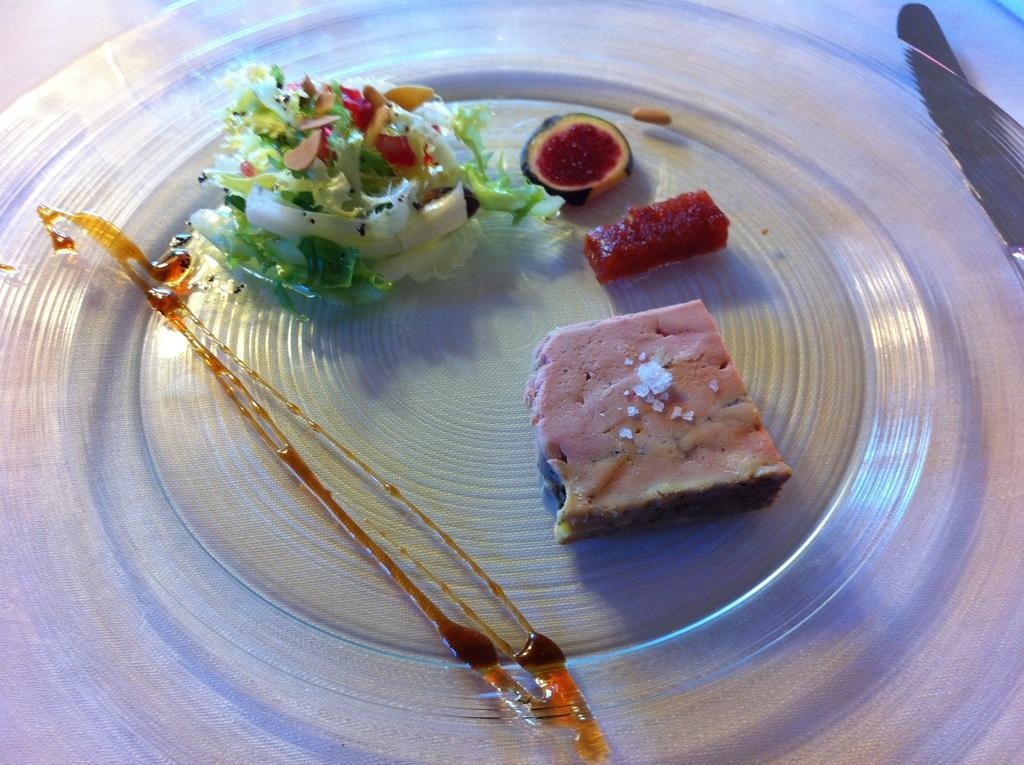Can you describe this image briefly? In this image I can see few food items are placed on a object which is made up of glass. In the top right-hand corner there is a knife. 